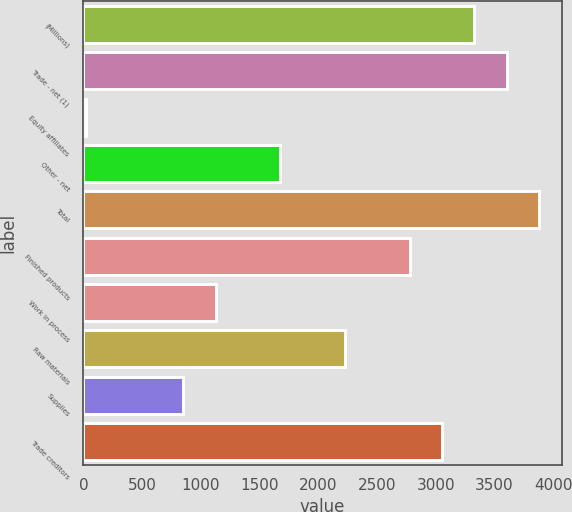Convert chart to OTSL. <chart><loc_0><loc_0><loc_500><loc_500><bar_chart><fcel>(Millions)<fcel>Trade - net (1)<fcel>Equity affiliates<fcel>Other - net<fcel>Total<fcel>Finished products<fcel>Work in process<fcel>Raw materials<fcel>Supplies<fcel>Trade creditors<nl><fcel>3328.8<fcel>3604.2<fcel>24<fcel>1676.4<fcel>3879.6<fcel>2778<fcel>1125.6<fcel>2227.2<fcel>850.2<fcel>3053.4<nl></chart> 